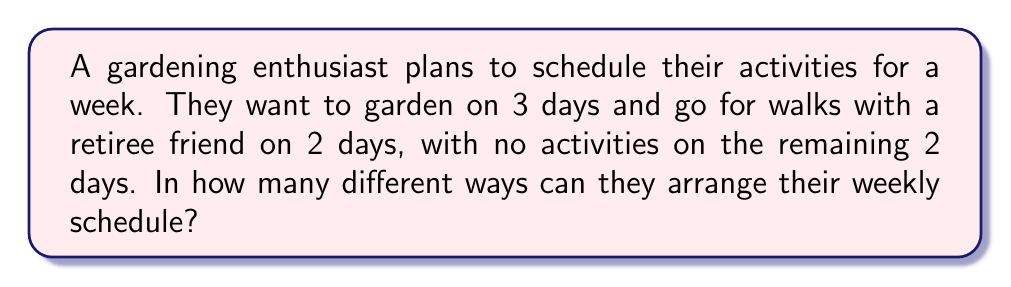Can you answer this question? Let's approach this step-by-step:

1) We have 7 days in a week, and we need to choose:
   - 3 days for gardening
   - 2 days for walks
   - 2 days for no activities

2) This is a combination problem, as the order of selection doesn't matter (e.g., gardening on Monday and Wednesday is the same as gardening on Wednesday and Monday).

3) We can solve this using the multiplication principle and combinations:

   Step 1: Choose 3 days for gardening out of 7 days
   $${7 \choose 3} = \frac{7!}{3!(7-3)!} = \frac{7!}{3!4!} = 35$$

   Step 2: From the remaining 4 days, choose 2 for walks
   $${4 \choose 2} = \frac{4!}{2!(4-2)!} = \frac{4!}{2!2!} = 6$$

   Step 3: The remaining 2 days will automatically be the no-activity days

4) By the multiplication principle, the total number of ways to arrange the schedule is:

   $$35 \times 6 = 210$$

Thus, there are 210 different ways to arrange the weekly schedule.
Answer: 210 ways 